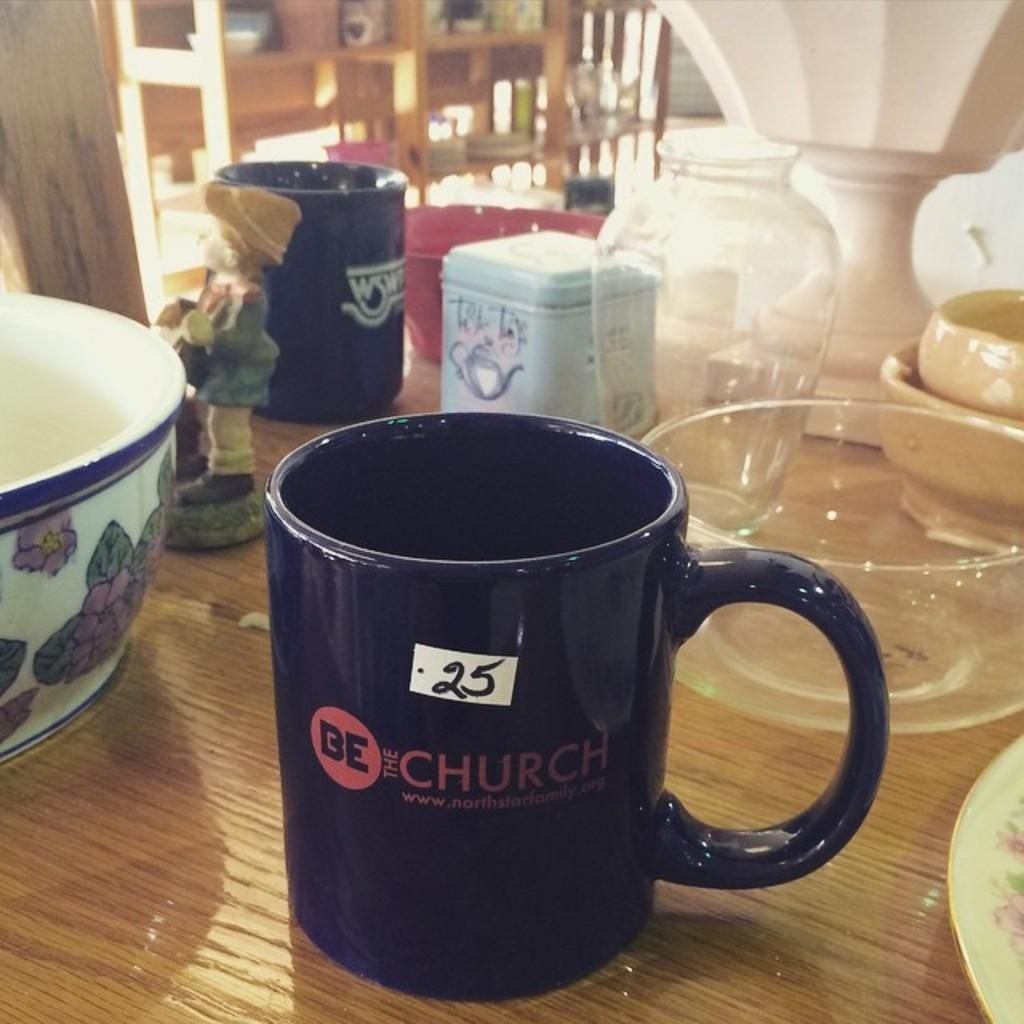<image>
Provide a brief description of the given image. A Church themed mug sits between two bowls. 